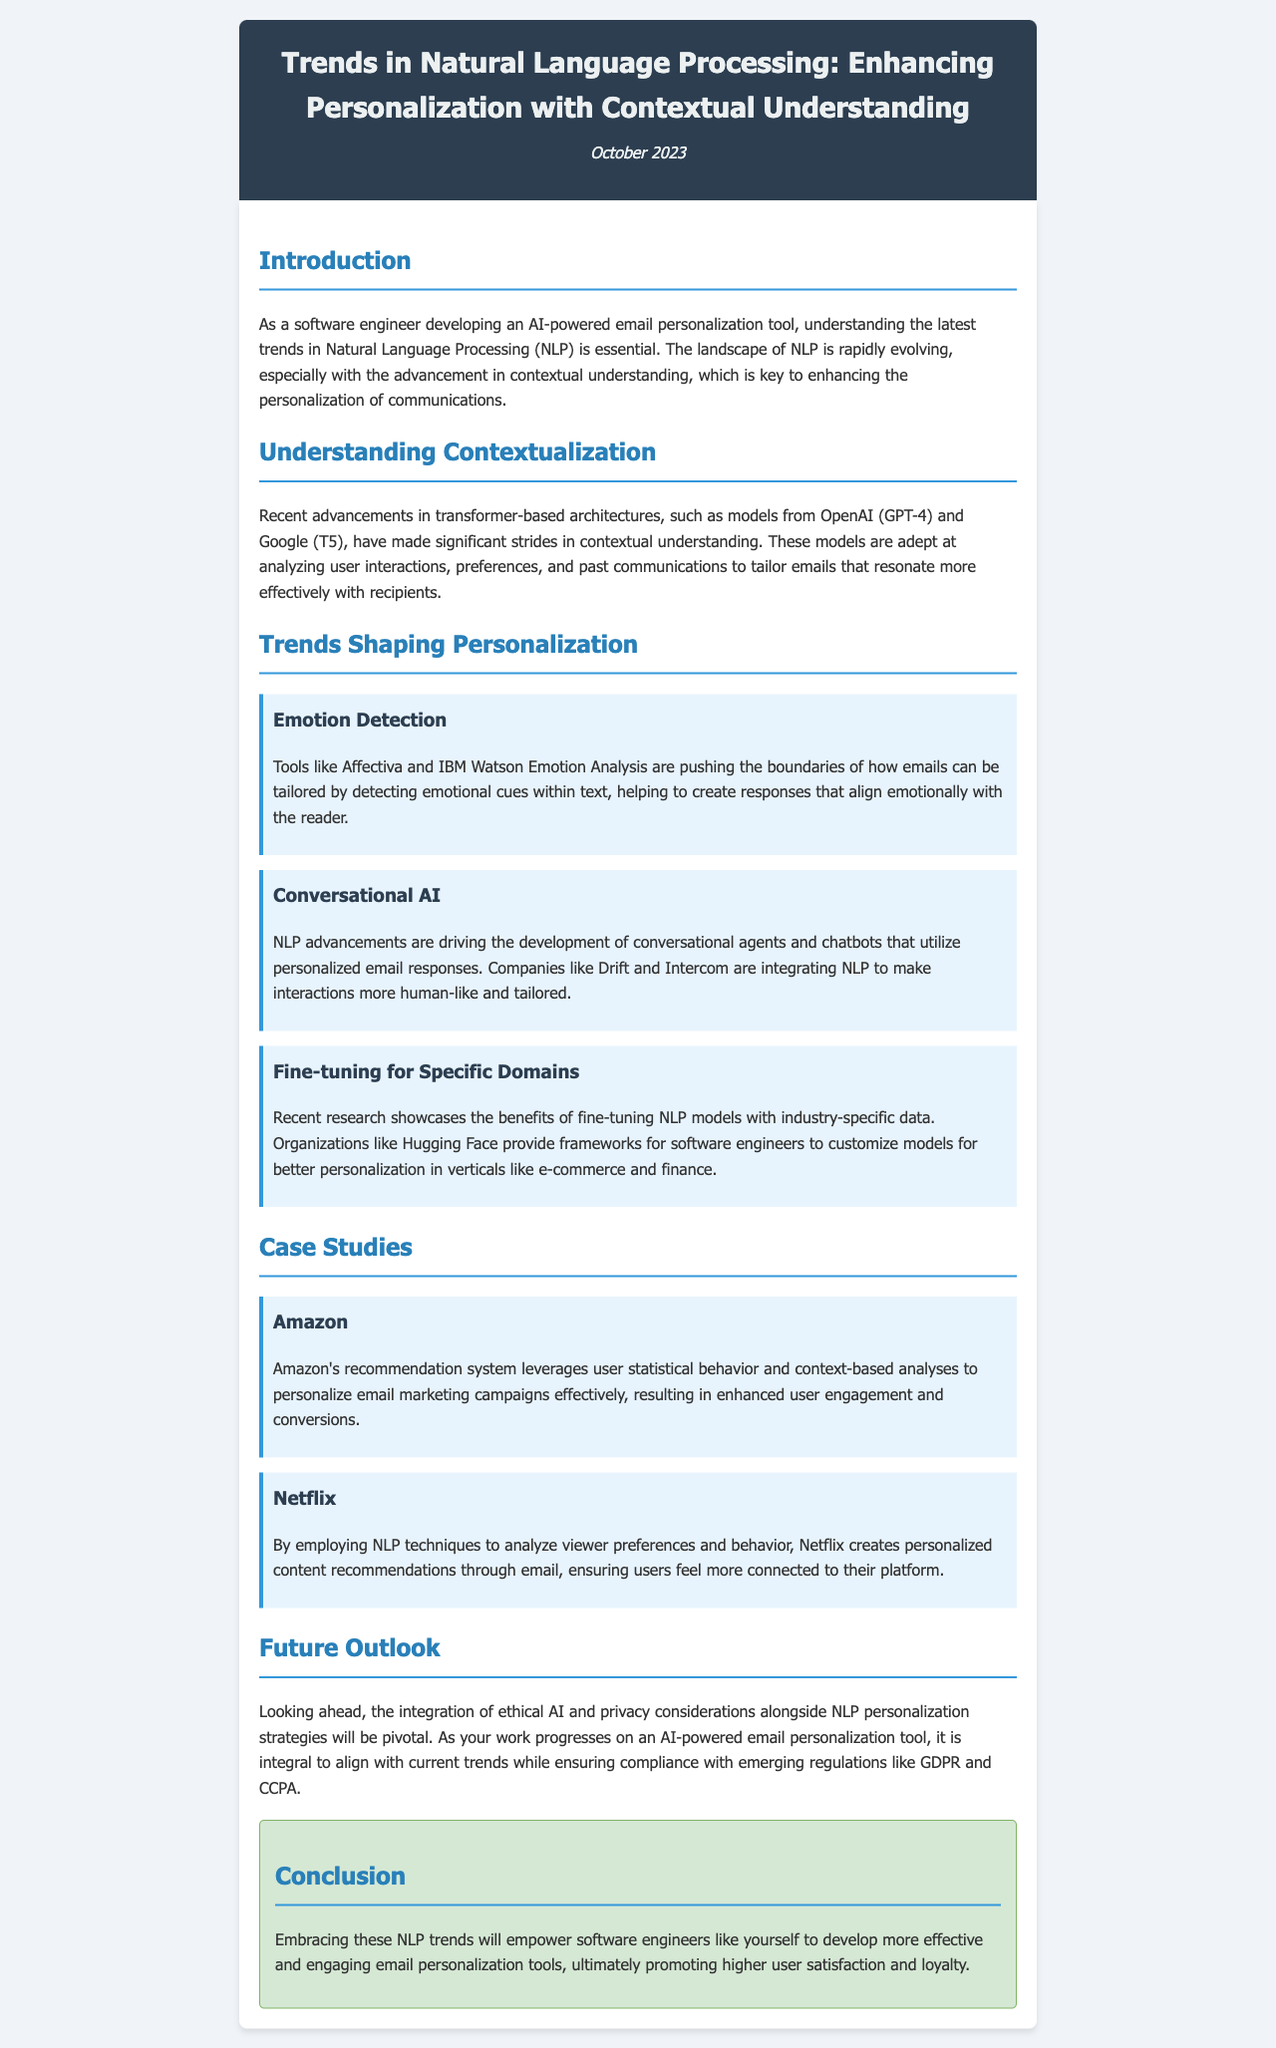What is the title of the newsletter? The title can be found in the header section of the document.
Answer: Trends in Natural Language Processing: Enhancing Personalization with Contextual Understanding Who published the newsletter? The author is not explicitly mentioned, but the content is directed toward software engineers in the context of NLP.
Answer: Software engineers What is the date of the newsletter? The date is specified in the header section of the document.
Answer: October 2023 Which model from OpenAI is mentioned in relation to contextual understanding? The document specifies the relevant model when discussing advancements in NLP.
Answer: GPT-4 What trend involves detecting emotional cues? The document lists specific trends, including one focused on emotion detection.
Answer: Emotion Detection Which company is cited as using NLP for personalized content recommendations? The document covers case studies that highlight specific organizations.
Answer: Netflix What ethical considerations are mentioned for future NLP development? The conclusion emphasizes the importance of certain aspects going forward in NLP trends.
Answer: Privacy considerations What type of architectures are discussed in the context of recent advancements? The document outlines the type of technology influencing contextual understanding.
Answer: Transformer-based architectures 